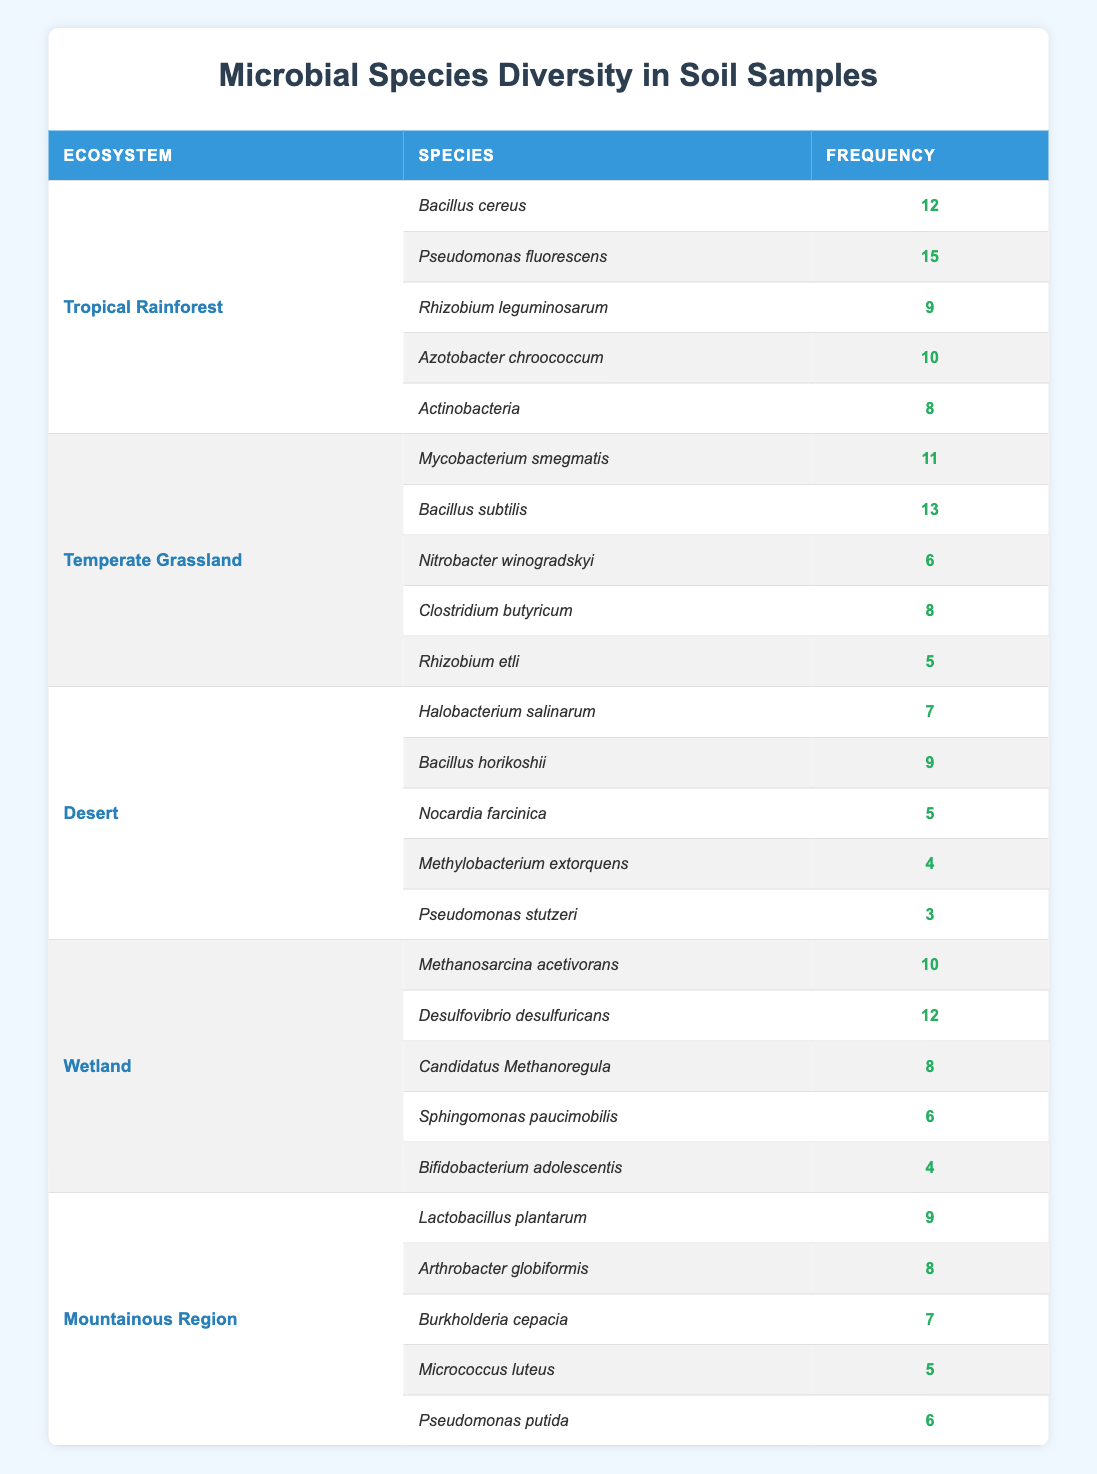What's the species with the highest frequency in the Tropical Rainforest ecosystem? In the Tropical Rainforest, we look at the frequencies of microbial species listed. The frequencies are 12 for Bacillus cereus, 15 for Pseudomonas fluorescens, 9 for Rhizobium leguminosarum, 10 for Azotobacter chroococcum, and 8 for Actinobacteria. Among these, Pseudomonas fluorescens has the highest frequency of 15.
Answer: 15 Which ecosystem has the least frequent microbial species based on the table? We compare the minimum frequencies listed for all ecosystems. The Desert ecosystem has Pseudomonas stutzeri with a frequency of 3, which is lower than all other ecosystems' least frequent species.
Answer: Desert What is the total frequency of microbial species in the Wetland ecosystem? For the Wetland ecosystem, we look at the frequencies: Methanosarcina acetivorans (10), Desulfovibrio desulfuricans (12), Candidatus Methanoregula (8), Sphingomonas paucimobilis (6), and Bifidobacterium adolescentis (4). Summing these gives us 10 + 12 + 8 + 6 + 4 = 40.
Answer: 40 Is Rhizobium leguminosarum more frequent than Rhizobium etli? We check Rhizobium leguminosarum in the Tropical Rainforest, which has a frequency of 9, and Rhizobium etli in the Temperate Grassland, which has a frequency of 5. Since 9 is greater than 5, it is true that Rhizobium leguminosarum is more frequent.
Answer: Yes What is the average frequency of microbial species in the Mountainous Region? We take the frequencies for the Mountainous Region: Lactobacillus plantarum (9), Arthrobacter globiformis (8), Burkholderia cepacia (7), Micrococcus luteus (5), and Pseudomonas putida (6). Adding these provides 9 + 8 + 7 + 5 + 6 = 35, then dividing by 5 gives an average of 35 / 5 = 7.
Answer: 7 Which ecosystem has the highest overall frequency of microbial species? We calculate total frequencies for each ecosystem: Tropical Rainforest (15 + 12 + 10 + 9 + 8 = 54), Temperate Grassland (13 + 11 + 8 + 6 + 5 = 43), Desert (9 + 7 + 5 + 4 + 3 = 28), Wetland (12 + 10 + 8 + 6 + 4 = 40), Mountainous Region (9 + 8 + 7 + 6 + 5 = 35). The highest total is the Tropical Rainforest at 54.
Answer: Tropical Rainforest Does the average frequency of species in the Desert ecosystem exceed 5? In the Desert ecosystem, the frequencies are 7, 9, 5, 4, and 3. To find the average, we sum up these frequencies: 7 + 9 + 5 + 4 + 3 = 28. Dividing by 5 gives an average of 28 / 5 = 5.6, which does exceed 5.
Answer: Yes What is the least frequent species in the Temperate Grassland? The species in the Temperate Grassland have frequencies of 11, 13, 6, 8, and 5. Here, Rhizobium etli has the lowest frequency of 5.
Answer: Rhizobium etli 